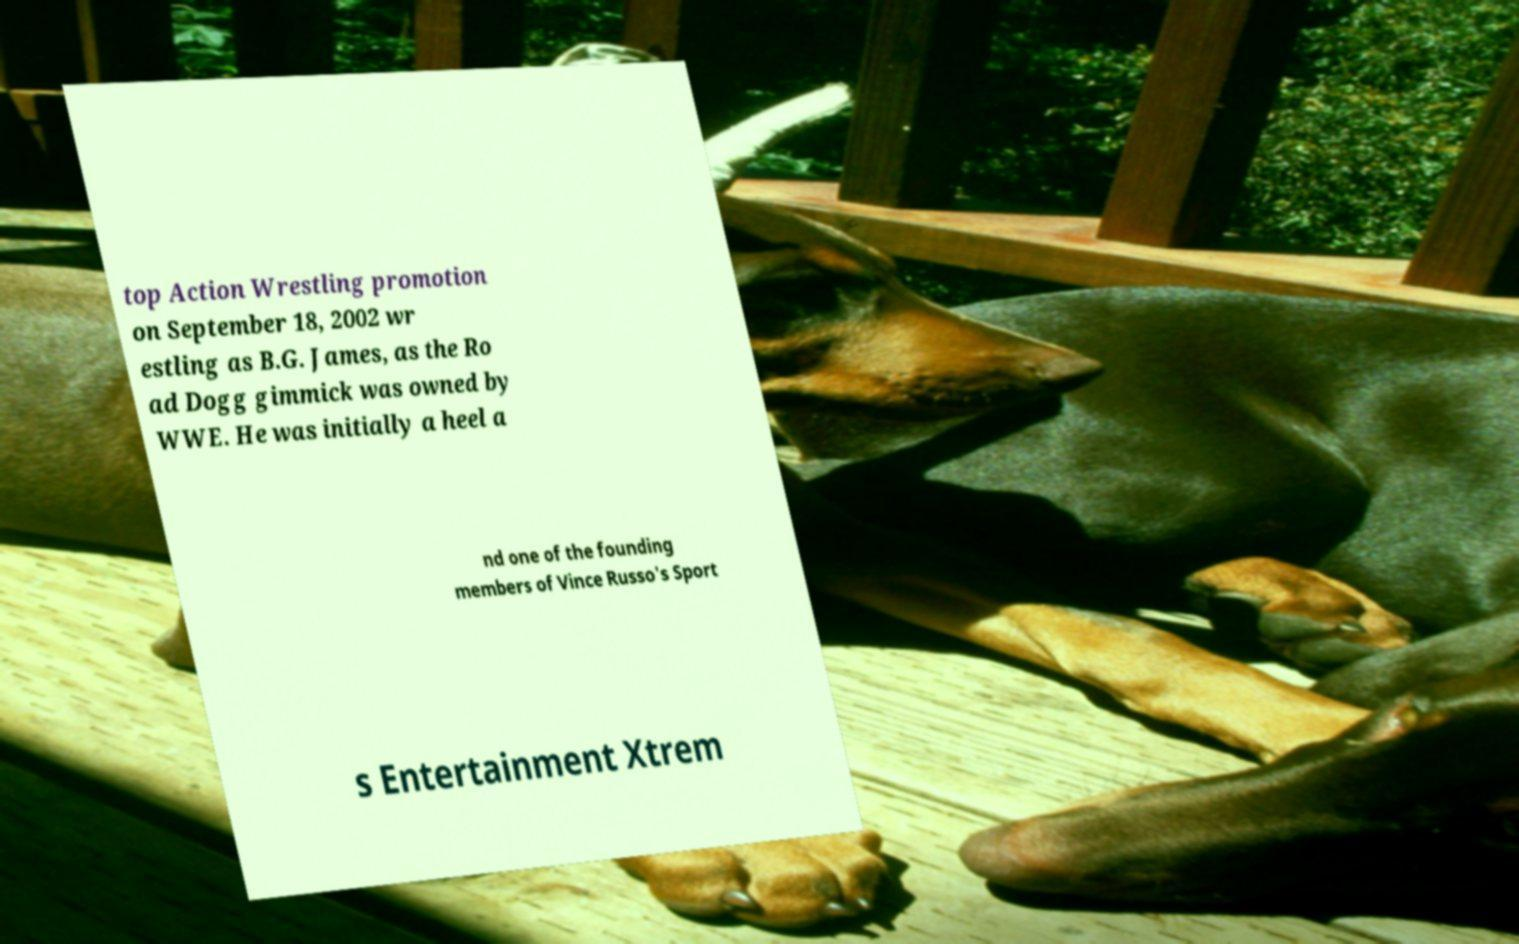Could you assist in decoding the text presented in this image and type it out clearly? top Action Wrestling promotion on September 18, 2002 wr estling as B.G. James, as the Ro ad Dogg gimmick was owned by WWE. He was initially a heel a nd one of the founding members of Vince Russo's Sport s Entertainment Xtrem 